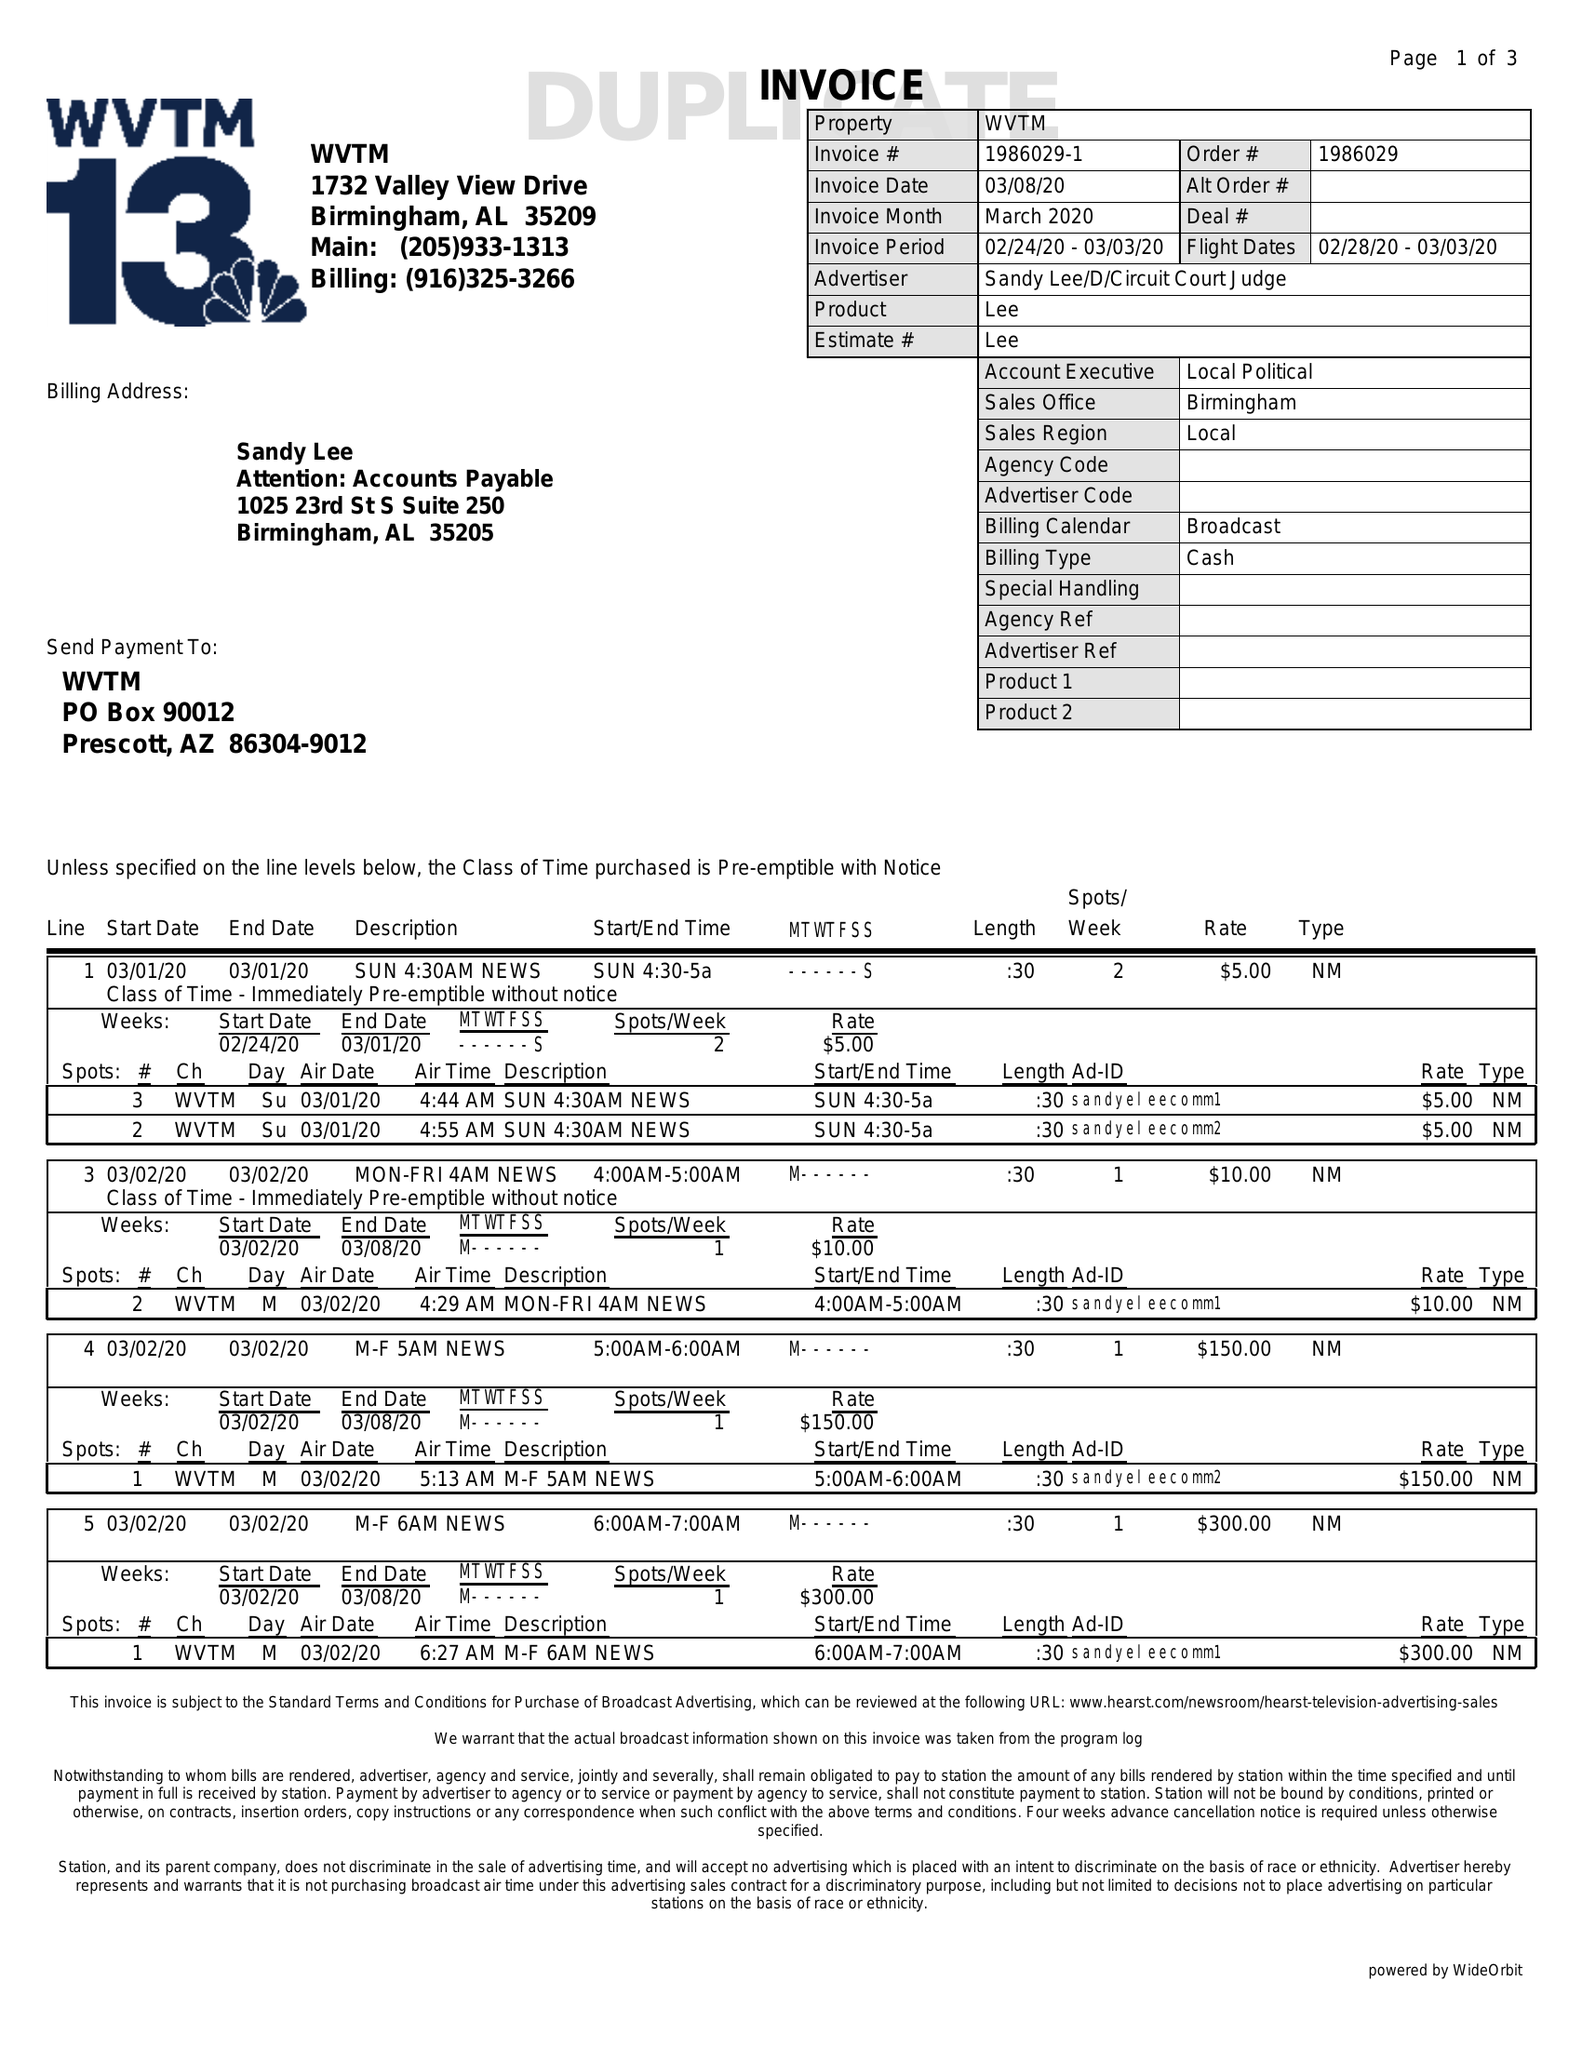What is the value for the flight_from?
Answer the question using a single word or phrase. 02/28/20 